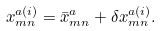Convert formula to latex. <formula><loc_0><loc_0><loc_500><loc_500>x ^ { a ( i ) } _ { m n } = \bar { x } ^ { a } _ { m n } + \delta x ^ { a ( i ) } _ { m n } .</formula> 